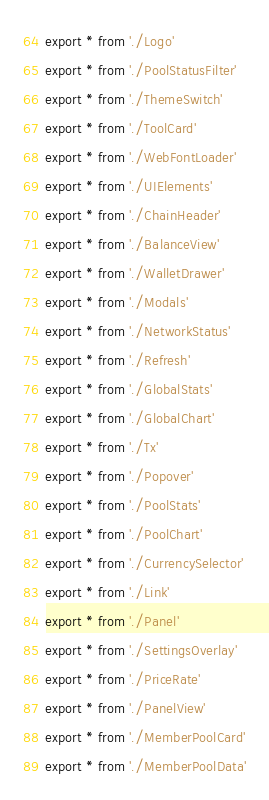<code> <loc_0><loc_0><loc_500><loc_500><_TypeScript_>export * from './Logo'
export * from './PoolStatusFilter'
export * from './ThemeSwitch'
export * from './ToolCard'
export * from './WebFontLoader'
export * from './UIElements'
export * from './ChainHeader'
export * from './BalanceView'
export * from './WalletDrawer'
export * from './Modals'
export * from './NetworkStatus'
export * from './Refresh'
export * from './GlobalStats'
export * from './GlobalChart'
export * from './Tx'
export * from './Popover'
export * from './PoolStats'
export * from './PoolChart'
export * from './CurrencySelector'
export * from './Link'
export * from './Panel'
export * from './SettingsOverlay'
export * from './PriceRate'
export * from './PanelView'
export * from './MemberPoolCard'
export * from './MemberPoolData'</code> 